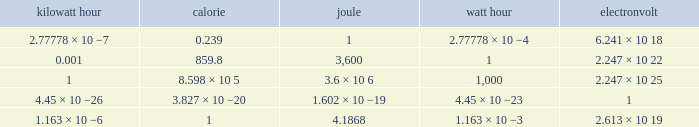How many calories is 1 watt hour? 859.8. 